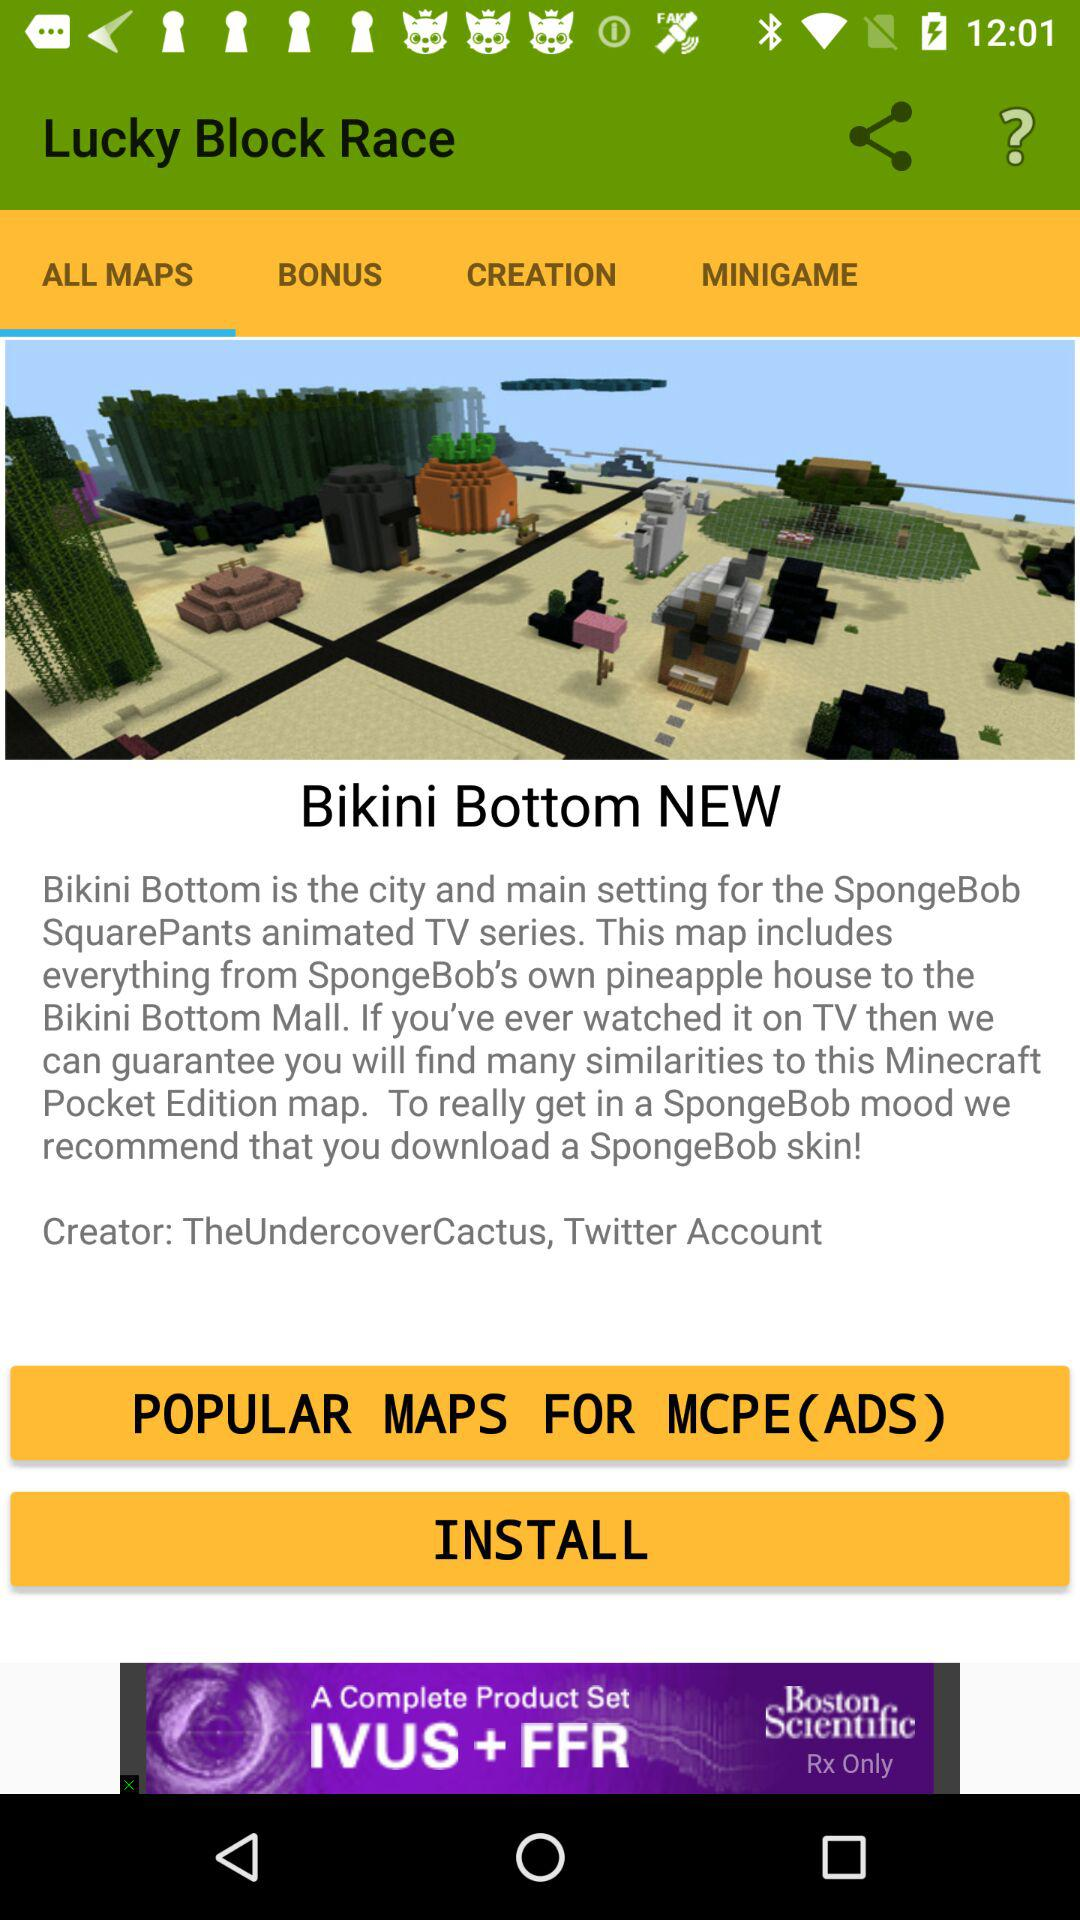What is the city name? The city name is Bikini Bottom. 